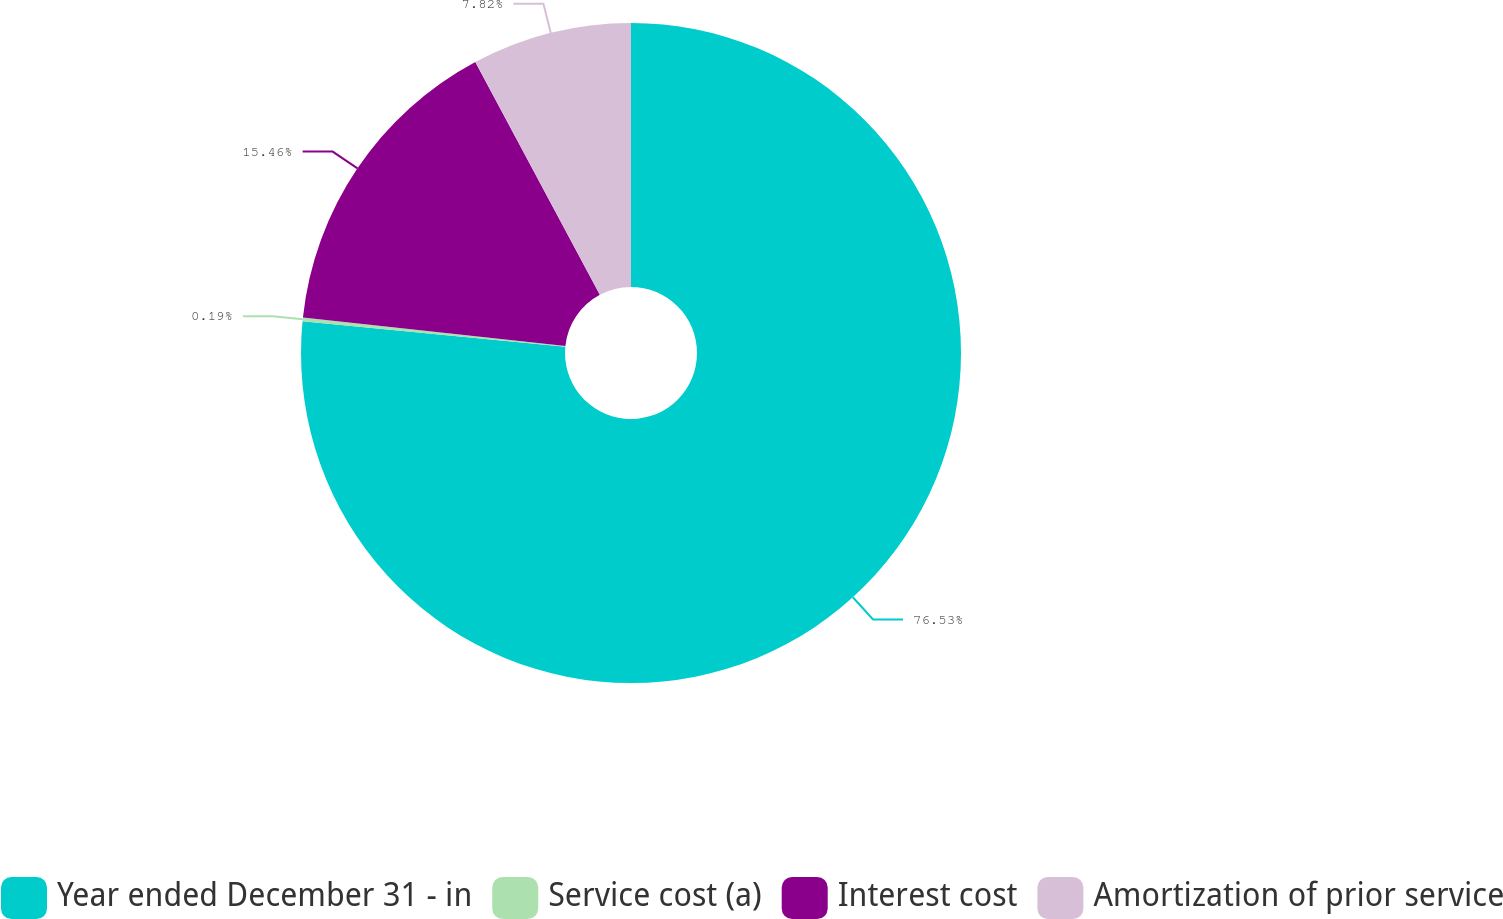Convert chart. <chart><loc_0><loc_0><loc_500><loc_500><pie_chart><fcel>Year ended December 31 - in<fcel>Service cost (a)<fcel>Interest cost<fcel>Amortization of prior service<nl><fcel>76.53%<fcel>0.19%<fcel>15.46%<fcel>7.82%<nl></chart> 